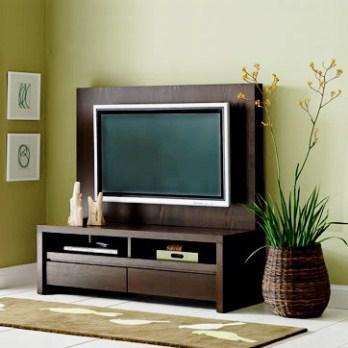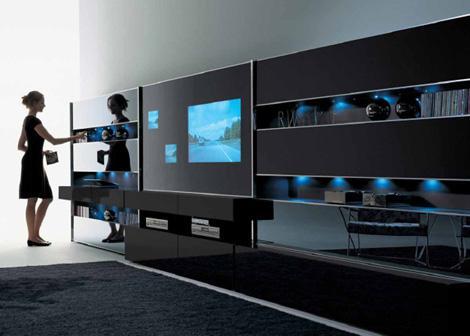The first image is the image on the left, the second image is the image on the right. Given the left and right images, does the statement "There are two people on the television on the left." hold true? Answer yes or no. No. 